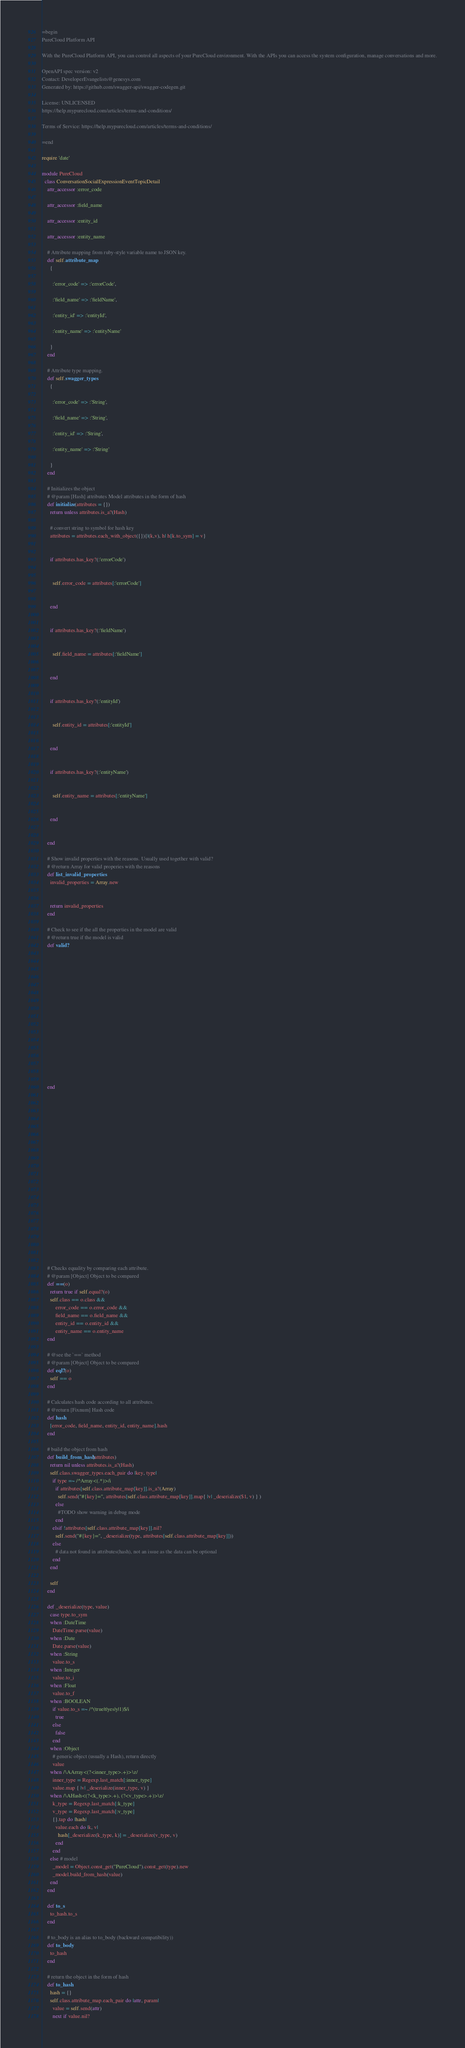<code> <loc_0><loc_0><loc_500><loc_500><_Ruby_>=begin
PureCloud Platform API

With the PureCloud Platform API, you can control all aspects of your PureCloud environment. With the APIs you can access the system configuration, manage conversations and more.

OpenAPI spec version: v2
Contact: DeveloperEvangelists@genesys.com
Generated by: https://github.com/swagger-api/swagger-codegen.git

License: UNLICENSED
https://help.mypurecloud.com/articles/terms-and-conditions/

Terms of Service: https://help.mypurecloud.com/articles/terms-and-conditions/

=end

require 'date'

module PureCloud
  class ConversationSocialExpressionEventTopicDetail
    attr_accessor :error_code

    attr_accessor :field_name

    attr_accessor :entity_id

    attr_accessor :entity_name

    # Attribute mapping from ruby-style variable name to JSON key.
    def self.attribute_map
      {
        
        :'error_code' => :'errorCode',
        
        :'field_name' => :'fieldName',
        
        :'entity_id' => :'entityId',
        
        :'entity_name' => :'entityName'
        
      }
    end

    # Attribute type mapping.
    def self.swagger_types
      {
        
        :'error_code' => :'String',
        
        :'field_name' => :'String',
        
        :'entity_id' => :'String',
        
        :'entity_name' => :'String'
        
      }
    end

    # Initializes the object
    # @param [Hash] attributes Model attributes in the form of hash
    def initialize(attributes = {})
      return unless attributes.is_a?(Hash)

      # convert string to symbol for hash key
      attributes = attributes.each_with_object({}){|(k,v), h| h[k.to_sym] = v}

      
      if attributes.has_key?(:'errorCode')
        
        
        self.error_code = attributes[:'errorCode']
        
      
      end

      
      if attributes.has_key?(:'fieldName')
        
        
        self.field_name = attributes[:'fieldName']
        
      
      end

      
      if attributes.has_key?(:'entityId')
        
        
        self.entity_id = attributes[:'entityId']
        
      
      end

      
      if attributes.has_key?(:'entityName')
        
        
        self.entity_name = attributes[:'entityName']
        
      
      end

      
    end

    # Show invalid properties with the reasons. Usually used together with valid?
    # @return Array for valid properies with the reasons
    def list_invalid_properties
      invalid_properties = Array.new
      
      
      return invalid_properties
    end

    # Check to see if the all the properties in the model are valid
    # @return true if the model is valid
    def valid?
      
      
      
      
      
      
      
      
      
      
      
      
      
      
      
      
      
    end

    
    
    
    
    
    
    
    
    
    
    
    
    
    
    
    
    
    
    
    
    
    # Checks equality by comparing each attribute.
    # @param [Object] Object to be compared
    def ==(o)
      return true if self.equal?(o)
      self.class == o.class &&
          error_code == o.error_code &&
          field_name == o.field_name &&
          entity_id == o.entity_id &&
          entity_name == o.entity_name
    end

    # @see the `==` method
    # @param [Object] Object to be compared
    def eql?(o)
      self == o
    end

    # Calculates hash code according to all attributes.
    # @return [Fixnum] Hash code
    def hash
      [error_code, field_name, entity_id, entity_name].hash
    end

    # build the object from hash
    def build_from_hash(attributes)
      return nil unless attributes.is_a?(Hash)
      self.class.swagger_types.each_pair do |key, type|
        if type =~ /^Array<(.*)>/i
          if attributes[self.class.attribute_map[key]].is_a?(Array)
            self.send("#{key}=", attributes[self.class.attribute_map[key]].map{ |v| _deserialize($1, v) } )
          else
            #TODO show warning in debug mode
          end
        elsif !attributes[self.class.attribute_map[key]].nil?
          self.send("#{key}=", _deserialize(type, attributes[self.class.attribute_map[key]]))
        else
          # data not found in attributes(hash), not an issue as the data can be optional
        end
      end

      self
    end

    def _deserialize(type, value)
      case type.to_sym
      when :DateTime
        DateTime.parse(value)
      when :Date
        Date.parse(value)
      when :String
        value.to_s
      when :Integer
        value.to_i
      when :Float
        value.to_f
      when :BOOLEAN
        if value.to_s =~ /^(true|t|yes|y|1)$/i
          true
        else
          false
        end
      when :Object
        # generic object (usually a Hash), return directly
        value
      when /\AArray<(?<inner_type>.+)>\z/
        inner_type = Regexp.last_match[:inner_type]
        value.map { |v| _deserialize(inner_type, v) }
      when /\AHash<(?<k_type>.+), (?<v_type>.+)>\z/
        k_type = Regexp.last_match[:k_type]
        v_type = Regexp.last_match[:v_type]
        {}.tap do |hash|
          value.each do |k, v|
            hash[_deserialize(k_type, k)] = _deserialize(v_type, v)
          end
        end
      else # model
        _model = Object.const_get("PureCloud").const_get(type).new
        _model.build_from_hash(value)
      end
    end

    def to_s
      to_hash.to_s
    end

    # to_body is an alias to to_body (backward compatibility))
    def to_body
      to_hash
    end

    # return the object in the form of hash
    def to_hash
      hash = {}
      self.class.attribute_map.each_pair do |attr, param|
        value = self.send(attr)
        next if value.nil?</code> 